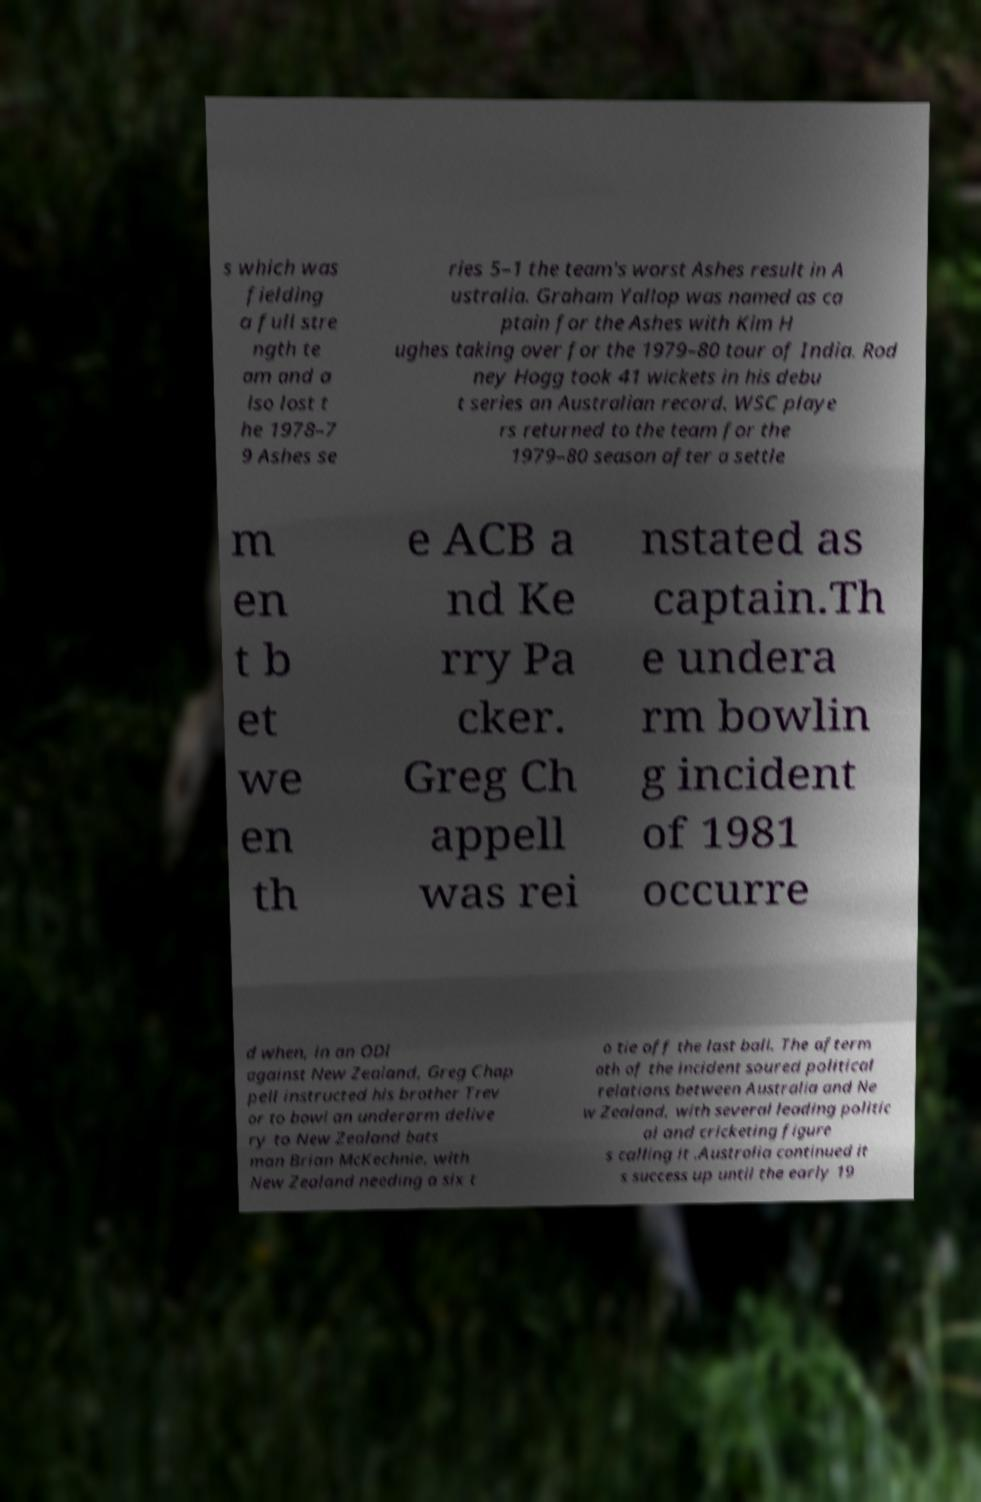There's text embedded in this image that I need extracted. Can you transcribe it verbatim? s which was fielding a full stre ngth te am and a lso lost t he 1978–7 9 Ashes se ries 5–1 the team's worst Ashes result in A ustralia. Graham Yallop was named as ca ptain for the Ashes with Kim H ughes taking over for the 1979–80 tour of India. Rod ney Hogg took 41 wickets in his debu t series an Australian record. WSC playe rs returned to the team for the 1979–80 season after a settle m en t b et we en th e ACB a nd Ke rry Pa cker. Greg Ch appell was rei nstated as captain.Th e undera rm bowlin g incident of 1981 occurre d when, in an ODI against New Zealand, Greg Chap pell instructed his brother Trev or to bowl an underarm delive ry to New Zealand bats man Brian McKechnie, with New Zealand needing a six t o tie off the last ball. The afterm ath of the incident soured political relations between Australia and Ne w Zealand, with several leading politic al and cricketing figure s calling it .Australia continued it s success up until the early 19 